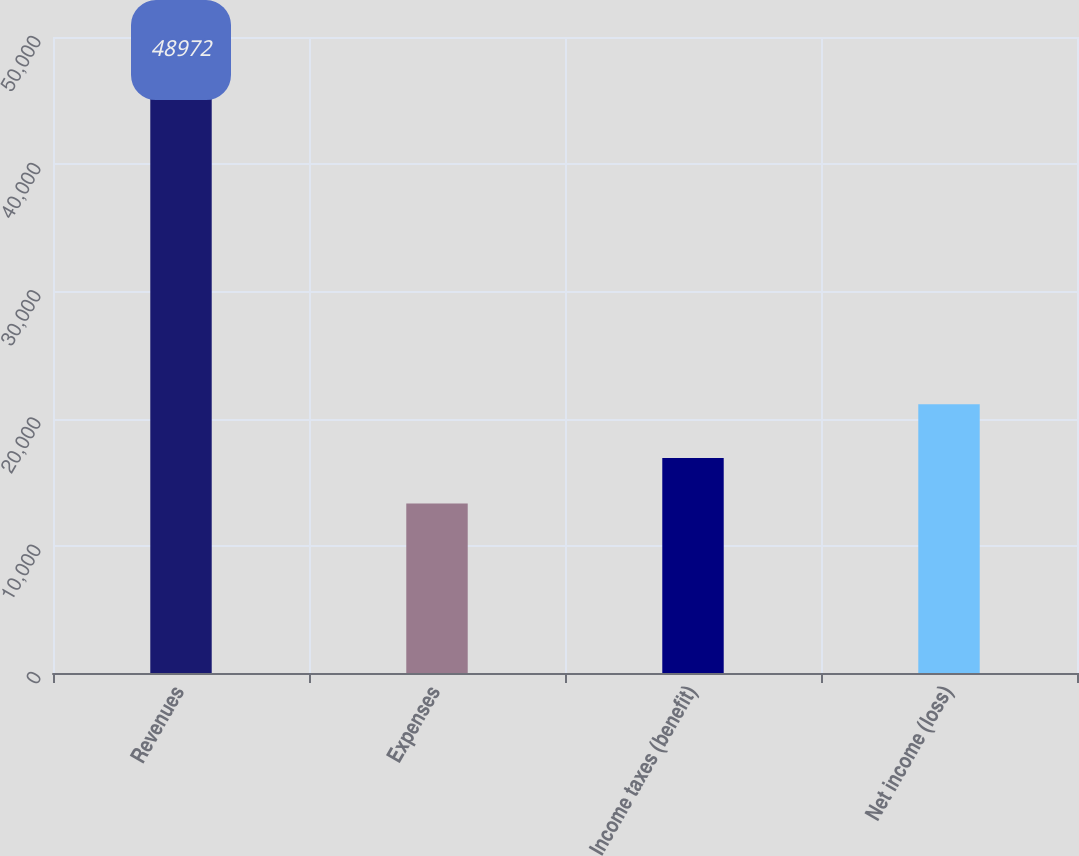<chart> <loc_0><loc_0><loc_500><loc_500><bar_chart><fcel>Revenues<fcel>Expenses<fcel>Income taxes (benefit)<fcel>Net income (loss)<nl><fcel>48972<fcel>13332<fcel>16896<fcel>21137<nl></chart> 